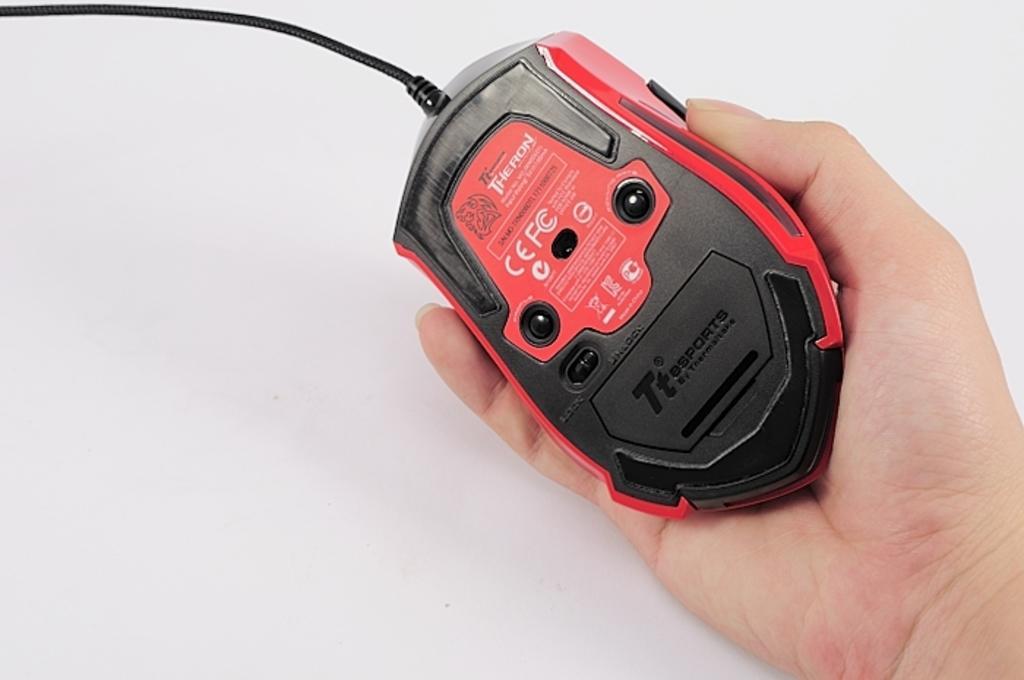Can you describe this image briefly? We can see mouse hold with hand. In the background it is white. 